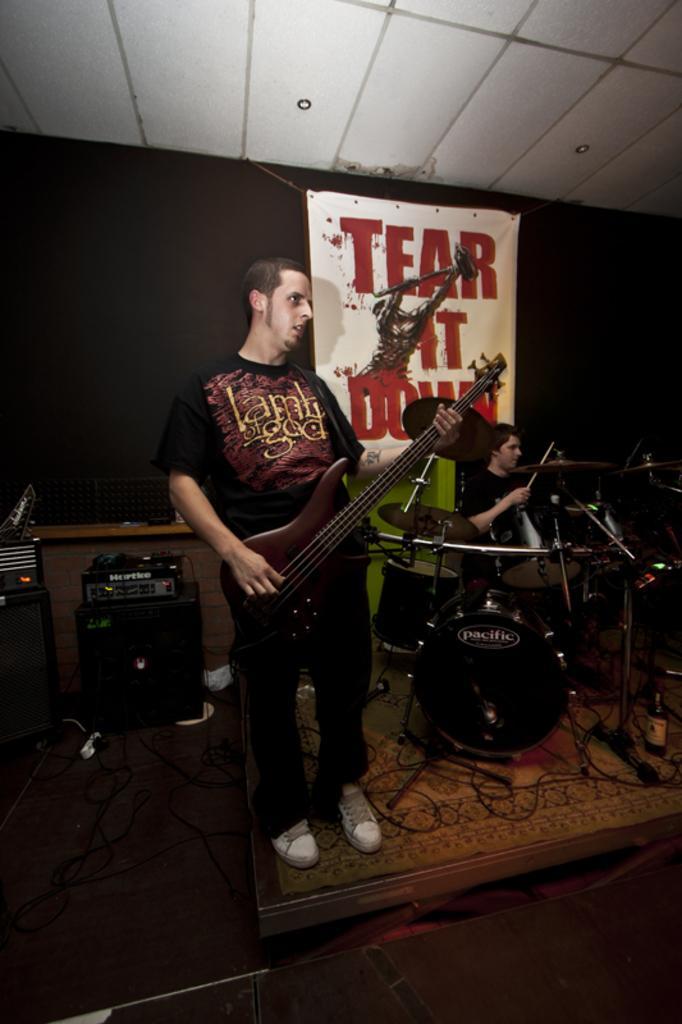Can you describe this image briefly? Here we can see a man with a guitar, playing the guitar and behind him we can see a man sitting on chair playing drums and behind them there is a banner written as tear it down 